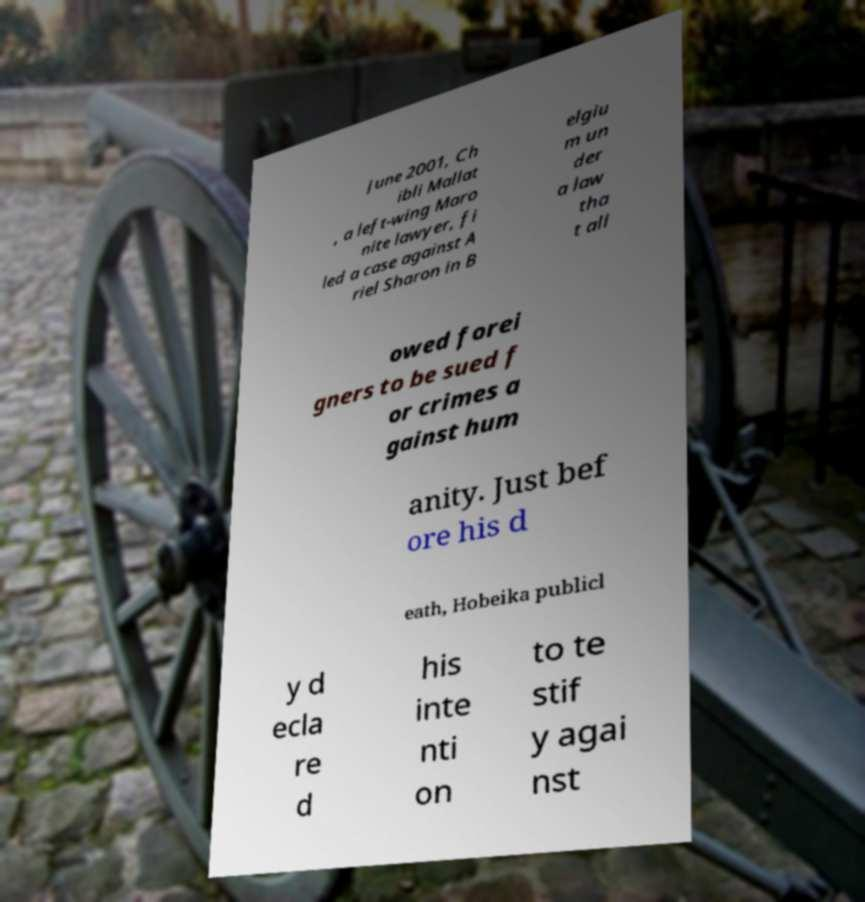Could you assist in decoding the text presented in this image and type it out clearly? June 2001, Ch ibli Mallat , a left-wing Maro nite lawyer, fi led a case against A riel Sharon in B elgiu m un der a law tha t all owed forei gners to be sued f or crimes a gainst hum anity. Just bef ore his d eath, Hobeika publicl y d ecla re d his inte nti on to te stif y agai nst 